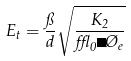<formula> <loc_0><loc_0><loc_500><loc_500>E _ { t } = \frac { \pi } { d } \sqrt { \frac { K _ { 2 } } { \epsilon _ { 0 } \Delta \chi _ { e } } }</formula> 